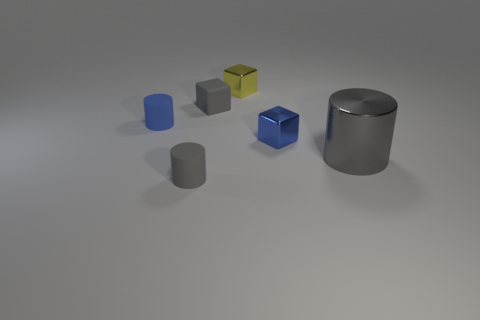Add 3 matte cylinders. How many objects exist? 9 Subtract all small cylinders. How many cylinders are left? 1 Subtract 2 cubes. How many cubes are left? 1 Subtract all purple blocks. Subtract all cyan cylinders. How many blocks are left? 3 Subtract all blue spheres. How many blue cubes are left? 1 Subtract all tiny blue matte cylinders. Subtract all large yellow spheres. How many objects are left? 5 Add 1 gray shiny cylinders. How many gray shiny cylinders are left? 2 Add 4 big purple metal spheres. How many big purple metal spheres exist? 4 Subtract all gray cylinders. How many cylinders are left? 1 Subtract 0 brown cubes. How many objects are left? 6 